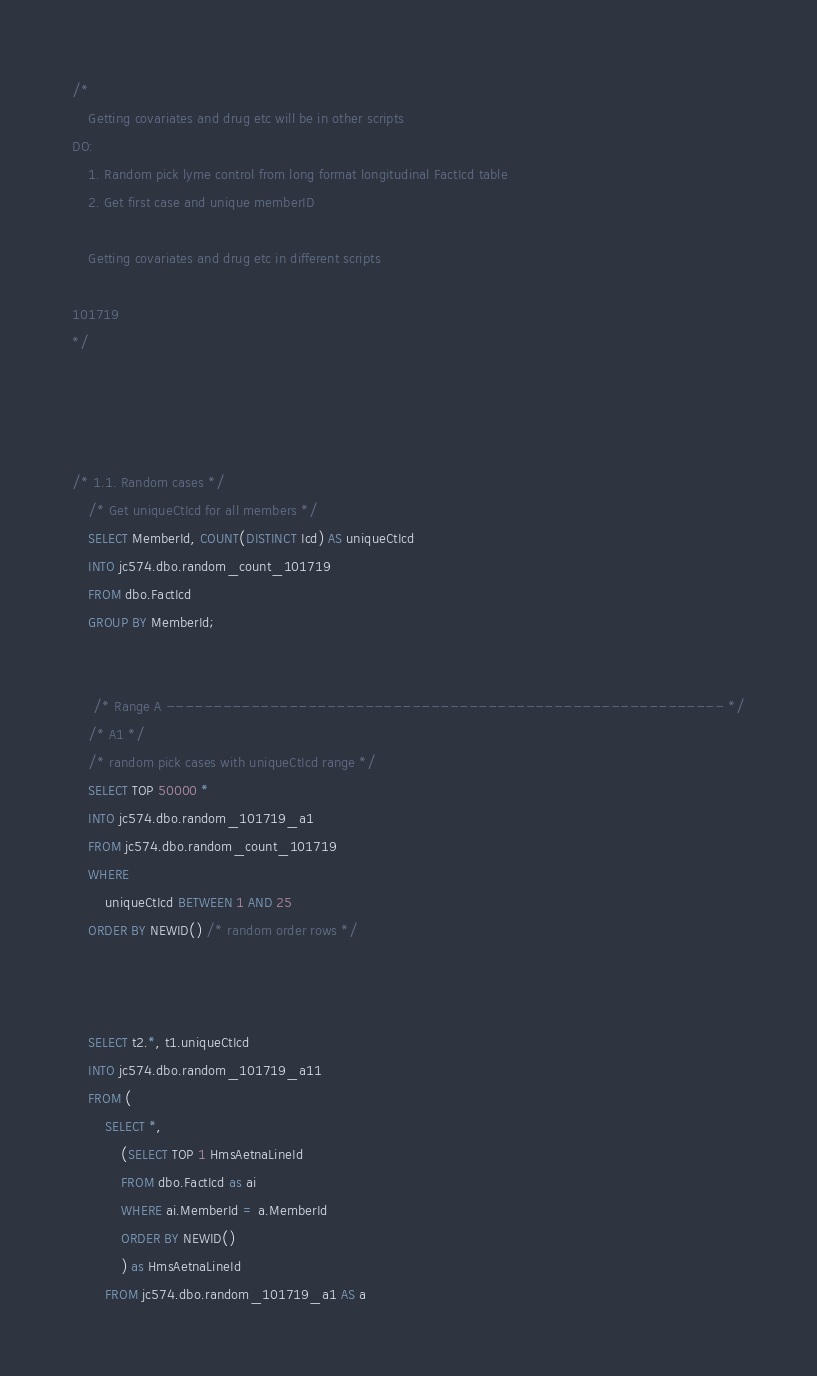Convert code to text. <code><loc_0><loc_0><loc_500><loc_500><_SQL_>/*
	Getting covariates and drug etc will be in other scripts
DO:
    1. Random pick lyme control from long format longitudinal FactIcd table
	2. Get first case and unique memberID
  
	Getting covariates and drug etc in different scripts

101719
*/




/* 1.1. Random cases */
	/* Get uniqueCtIcd for all members */
	SELECT MemberId, COUNT(DISTINCT Icd) AS uniqueCtIcd
    INTO jc574.dbo.random_count_101719
    FROM dbo.FactIcd
    GROUP BY MemberId;
	

     /* Range A ----------------------------------------------------------- */
	/* A1 */
	/* random pick cases with uniqueCtIcd range */
	SELECT TOP 50000 *
	INTO jc574.dbo.random_101719_a1
	FROM jc574.dbo.random_count_101719
	WHERE
		uniqueCtIcd BETWEEN 1 AND 25
	ORDER BY NEWID() /* random order rows */


	
    SELECT t2.*, t1.uniqueCtIcd
    INTO jc574.dbo.random_101719_a11
    FROM (
    	SELECT *, 
			(SELECT TOP 1 HmsAetnaLineId 
			FROM dbo.FactIcd as ai
			WHERE ai.MemberId = a.MemberId
			ORDER BY NEWID()
			) as HmsAetnaLineId
		FROM jc574.dbo.random_101719_a1 AS a </code> 